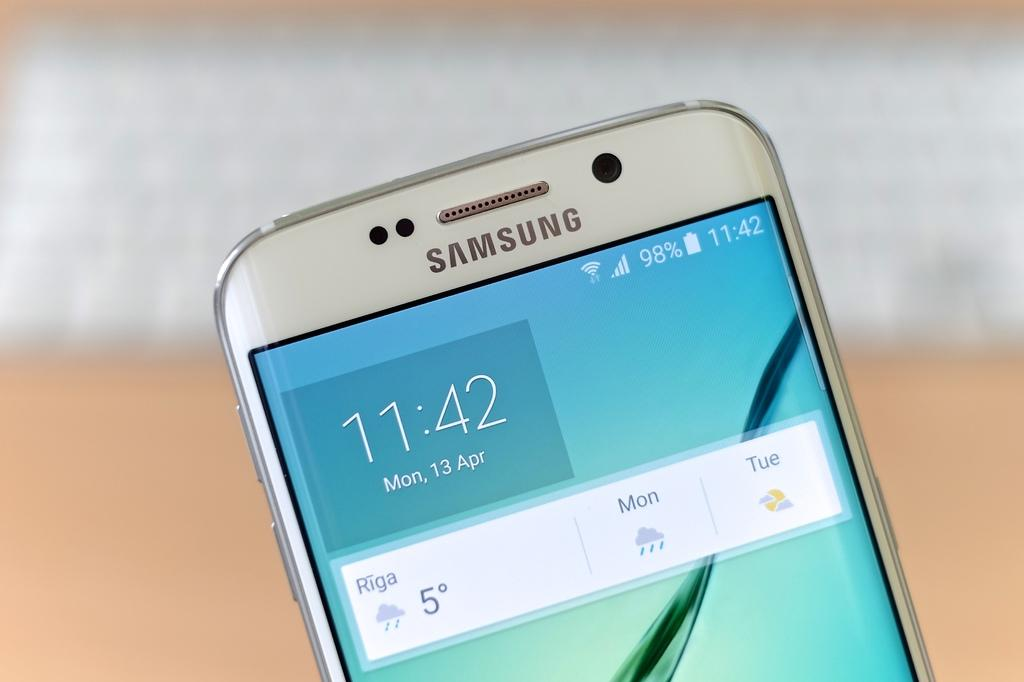<image>
Offer a succinct explanation of the picture presented. A silver Samsung phone shows that it is 11:42 on Monday, April 13th. 